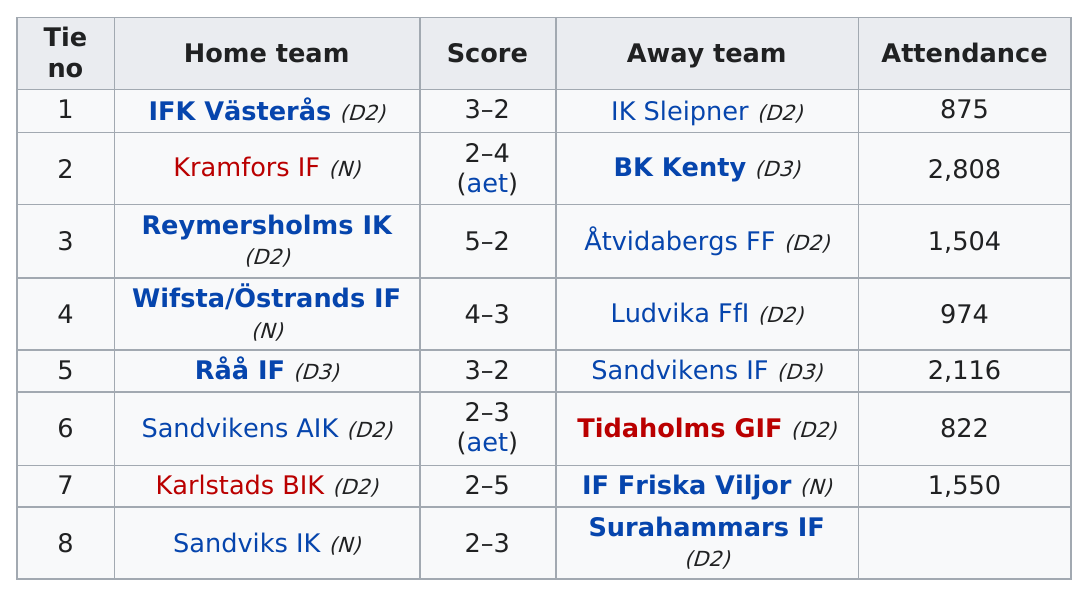List a handful of essential elements in this visual. The total number of teams listed is 16. I'm sorry, but I'm not sure what you are asking. "Did tie number 4 or tie number 6 have higher attendance?" is a question that is asking for information about two ties and their attendance levels. It is not clear what you are trying to ask with the phrase "4.." at the end. Can you please provide more context or rephrase your question? Is Ludvika a D3 or a D2? It is a D2. Which tie number has the same score as tie number 5? There were four games in which the score was 2-3 or 3-2. 